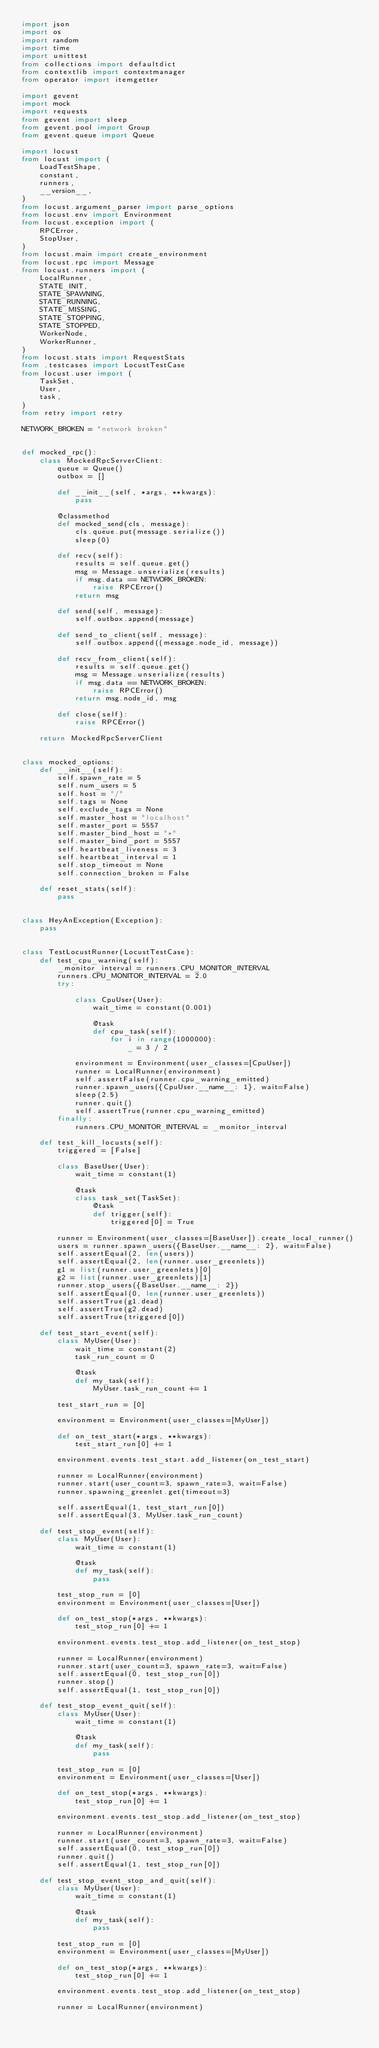Convert code to text. <code><loc_0><loc_0><loc_500><loc_500><_Python_>import json
import os
import random
import time
import unittest
from collections import defaultdict
from contextlib import contextmanager
from operator import itemgetter

import gevent
import mock
import requests
from gevent import sleep
from gevent.pool import Group
from gevent.queue import Queue

import locust
from locust import (
    LoadTestShape,
    constant,
    runners,
    __version__,
)
from locust.argument_parser import parse_options
from locust.env import Environment
from locust.exception import (
    RPCError,
    StopUser,
)
from locust.main import create_environment
from locust.rpc import Message
from locust.runners import (
    LocalRunner,
    STATE_INIT,
    STATE_SPAWNING,
    STATE_RUNNING,
    STATE_MISSING,
    STATE_STOPPING,
    STATE_STOPPED,
    WorkerNode,
    WorkerRunner,
)
from locust.stats import RequestStats
from .testcases import LocustTestCase
from locust.user import (
    TaskSet,
    User,
    task,
)
from retry import retry

NETWORK_BROKEN = "network broken"


def mocked_rpc():
    class MockedRpcServerClient:
        queue = Queue()
        outbox = []

        def __init__(self, *args, **kwargs):
            pass

        @classmethod
        def mocked_send(cls, message):
            cls.queue.put(message.serialize())
            sleep(0)

        def recv(self):
            results = self.queue.get()
            msg = Message.unserialize(results)
            if msg.data == NETWORK_BROKEN:
                raise RPCError()
            return msg

        def send(self, message):
            self.outbox.append(message)

        def send_to_client(self, message):
            self.outbox.append((message.node_id, message))

        def recv_from_client(self):
            results = self.queue.get()
            msg = Message.unserialize(results)
            if msg.data == NETWORK_BROKEN:
                raise RPCError()
            return msg.node_id, msg

        def close(self):
            raise RPCError()

    return MockedRpcServerClient


class mocked_options:
    def __init__(self):
        self.spawn_rate = 5
        self.num_users = 5
        self.host = "/"
        self.tags = None
        self.exclude_tags = None
        self.master_host = "localhost"
        self.master_port = 5557
        self.master_bind_host = "*"
        self.master_bind_port = 5557
        self.heartbeat_liveness = 3
        self.heartbeat_interval = 1
        self.stop_timeout = None
        self.connection_broken = False

    def reset_stats(self):
        pass


class HeyAnException(Exception):
    pass


class TestLocustRunner(LocustTestCase):
    def test_cpu_warning(self):
        _monitor_interval = runners.CPU_MONITOR_INTERVAL
        runners.CPU_MONITOR_INTERVAL = 2.0
        try:

            class CpuUser(User):
                wait_time = constant(0.001)

                @task
                def cpu_task(self):
                    for i in range(1000000):
                        _ = 3 / 2

            environment = Environment(user_classes=[CpuUser])
            runner = LocalRunner(environment)
            self.assertFalse(runner.cpu_warning_emitted)
            runner.spawn_users({CpuUser.__name__: 1}, wait=False)
            sleep(2.5)
            runner.quit()
            self.assertTrue(runner.cpu_warning_emitted)
        finally:
            runners.CPU_MONITOR_INTERVAL = _monitor_interval

    def test_kill_locusts(self):
        triggered = [False]

        class BaseUser(User):
            wait_time = constant(1)

            @task
            class task_set(TaskSet):
                @task
                def trigger(self):
                    triggered[0] = True

        runner = Environment(user_classes=[BaseUser]).create_local_runner()
        users = runner.spawn_users({BaseUser.__name__: 2}, wait=False)
        self.assertEqual(2, len(users))
        self.assertEqual(2, len(runner.user_greenlets))
        g1 = list(runner.user_greenlets)[0]
        g2 = list(runner.user_greenlets)[1]
        runner.stop_users({BaseUser.__name__: 2})
        self.assertEqual(0, len(runner.user_greenlets))
        self.assertTrue(g1.dead)
        self.assertTrue(g2.dead)
        self.assertTrue(triggered[0])

    def test_start_event(self):
        class MyUser(User):
            wait_time = constant(2)
            task_run_count = 0

            @task
            def my_task(self):
                MyUser.task_run_count += 1

        test_start_run = [0]

        environment = Environment(user_classes=[MyUser])

        def on_test_start(*args, **kwargs):
            test_start_run[0] += 1

        environment.events.test_start.add_listener(on_test_start)

        runner = LocalRunner(environment)
        runner.start(user_count=3, spawn_rate=3, wait=False)
        runner.spawning_greenlet.get(timeout=3)

        self.assertEqual(1, test_start_run[0])
        self.assertEqual(3, MyUser.task_run_count)

    def test_stop_event(self):
        class MyUser(User):
            wait_time = constant(1)

            @task
            def my_task(self):
                pass

        test_stop_run = [0]
        environment = Environment(user_classes=[User])

        def on_test_stop(*args, **kwargs):
            test_stop_run[0] += 1

        environment.events.test_stop.add_listener(on_test_stop)

        runner = LocalRunner(environment)
        runner.start(user_count=3, spawn_rate=3, wait=False)
        self.assertEqual(0, test_stop_run[0])
        runner.stop()
        self.assertEqual(1, test_stop_run[0])

    def test_stop_event_quit(self):
        class MyUser(User):
            wait_time = constant(1)

            @task
            def my_task(self):
                pass

        test_stop_run = [0]
        environment = Environment(user_classes=[User])

        def on_test_stop(*args, **kwargs):
            test_stop_run[0] += 1

        environment.events.test_stop.add_listener(on_test_stop)

        runner = LocalRunner(environment)
        runner.start(user_count=3, spawn_rate=3, wait=False)
        self.assertEqual(0, test_stop_run[0])
        runner.quit()
        self.assertEqual(1, test_stop_run[0])

    def test_stop_event_stop_and_quit(self):
        class MyUser(User):
            wait_time = constant(1)

            @task
            def my_task(self):
                pass

        test_stop_run = [0]
        environment = Environment(user_classes=[MyUser])

        def on_test_stop(*args, **kwargs):
            test_stop_run[0] += 1

        environment.events.test_stop.add_listener(on_test_stop)

        runner = LocalRunner(environment)</code> 